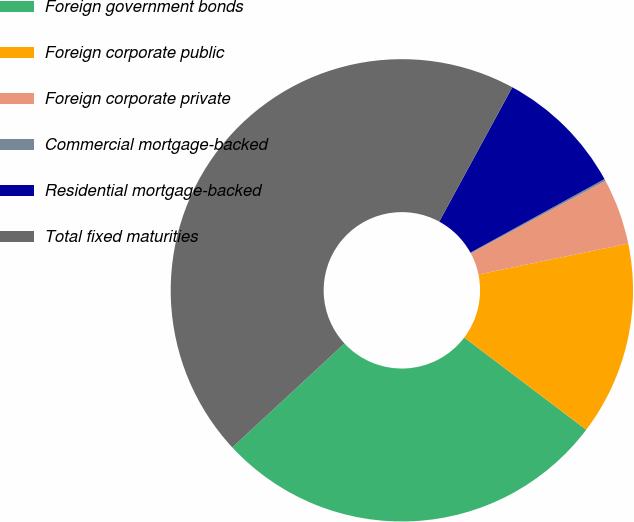Convert chart to OTSL. <chart><loc_0><loc_0><loc_500><loc_500><pie_chart><fcel>Foreign government bonds<fcel>Foreign corporate public<fcel>Foreign corporate private<fcel>Commercial mortgage-backed<fcel>Residential mortgage-backed<fcel>Total fixed maturities<nl><fcel>27.8%<fcel>13.55%<fcel>4.61%<fcel>0.14%<fcel>9.08%<fcel>44.82%<nl></chart> 